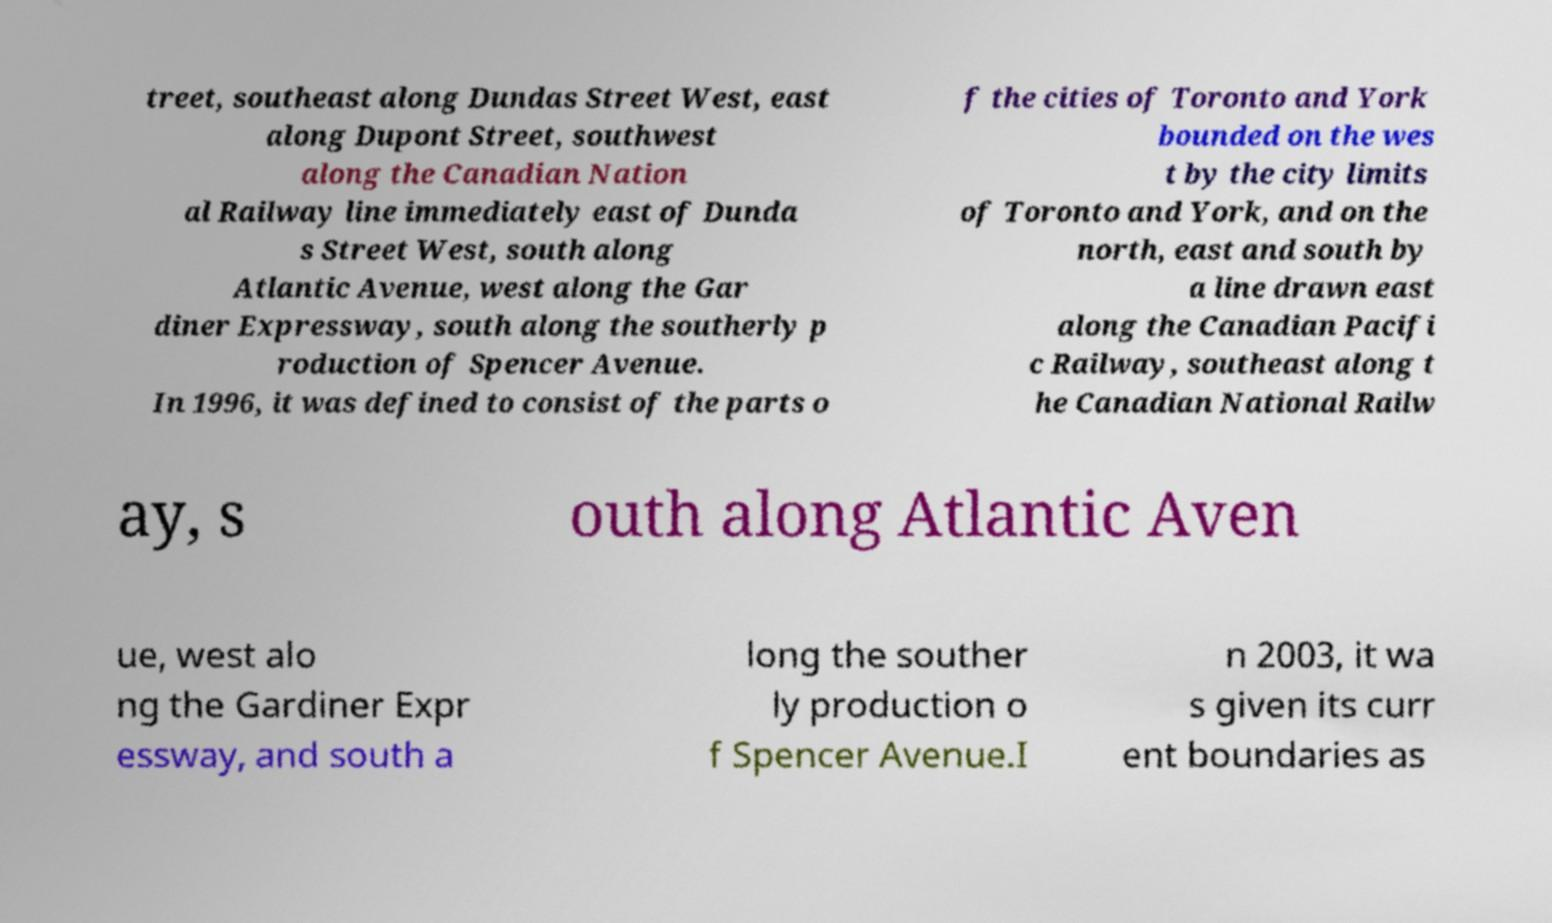For documentation purposes, I need the text within this image transcribed. Could you provide that? treet, southeast along Dundas Street West, east along Dupont Street, southwest along the Canadian Nation al Railway line immediately east of Dunda s Street West, south along Atlantic Avenue, west along the Gar diner Expressway, south along the southerly p roduction of Spencer Avenue. In 1996, it was defined to consist of the parts o f the cities of Toronto and York bounded on the wes t by the city limits of Toronto and York, and on the north, east and south by a line drawn east along the Canadian Pacifi c Railway, southeast along t he Canadian National Railw ay, s outh along Atlantic Aven ue, west alo ng the Gardiner Expr essway, and south a long the souther ly production o f Spencer Avenue.I n 2003, it wa s given its curr ent boundaries as 